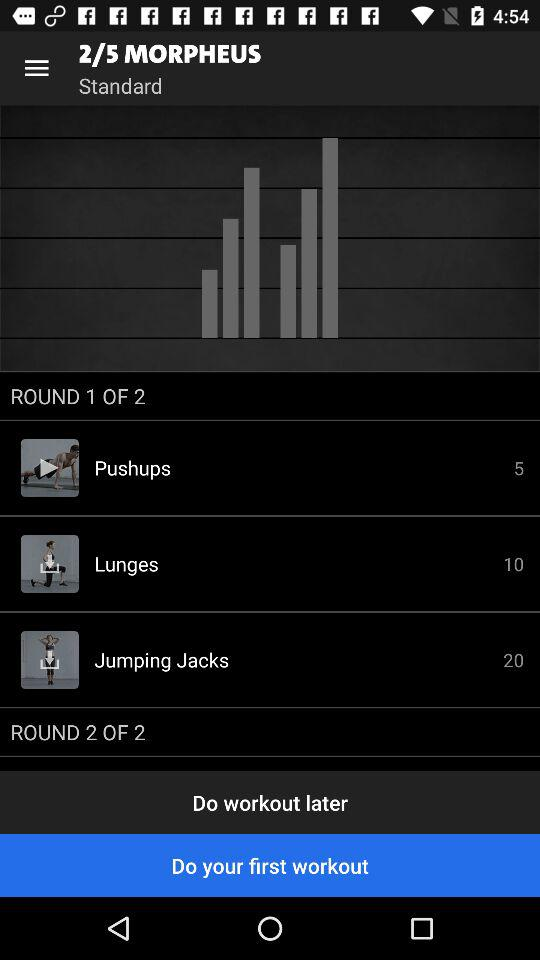What is the total number of rounds? The total number of rounds is 2. 